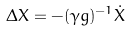<formula> <loc_0><loc_0><loc_500><loc_500>\Delta X = - ( \gamma g ) ^ { - 1 } \dot { X }</formula> 